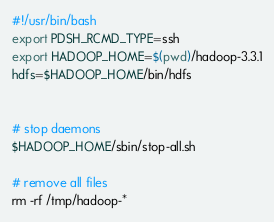<code> <loc_0><loc_0><loc_500><loc_500><_Bash_>#!/usr/bin/bash
export PDSH_RCMD_TYPE=ssh
export HADOOP_HOME=$(pwd)/hadoop-3.3.1
hdfs=$HADOOP_HOME/bin/hdfs


# stop daemons
$HADOOP_HOME/sbin/stop-all.sh

# remove all files
rm -rf /tmp/hadoop-*
</code> 